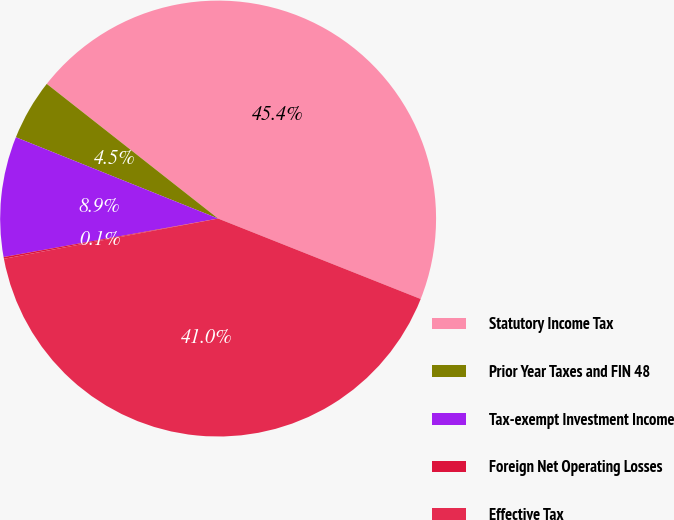Convert chart to OTSL. <chart><loc_0><loc_0><loc_500><loc_500><pie_chart><fcel>Statutory Income Tax<fcel>Prior Year Taxes and FIN 48<fcel>Tax-exempt Investment Income<fcel>Foreign Net Operating Losses<fcel>Effective Tax<nl><fcel>45.42%<fcel>4.52%<fcel>8.91%<fcel>0.13%<fcel>41.03%<nl></chart> 